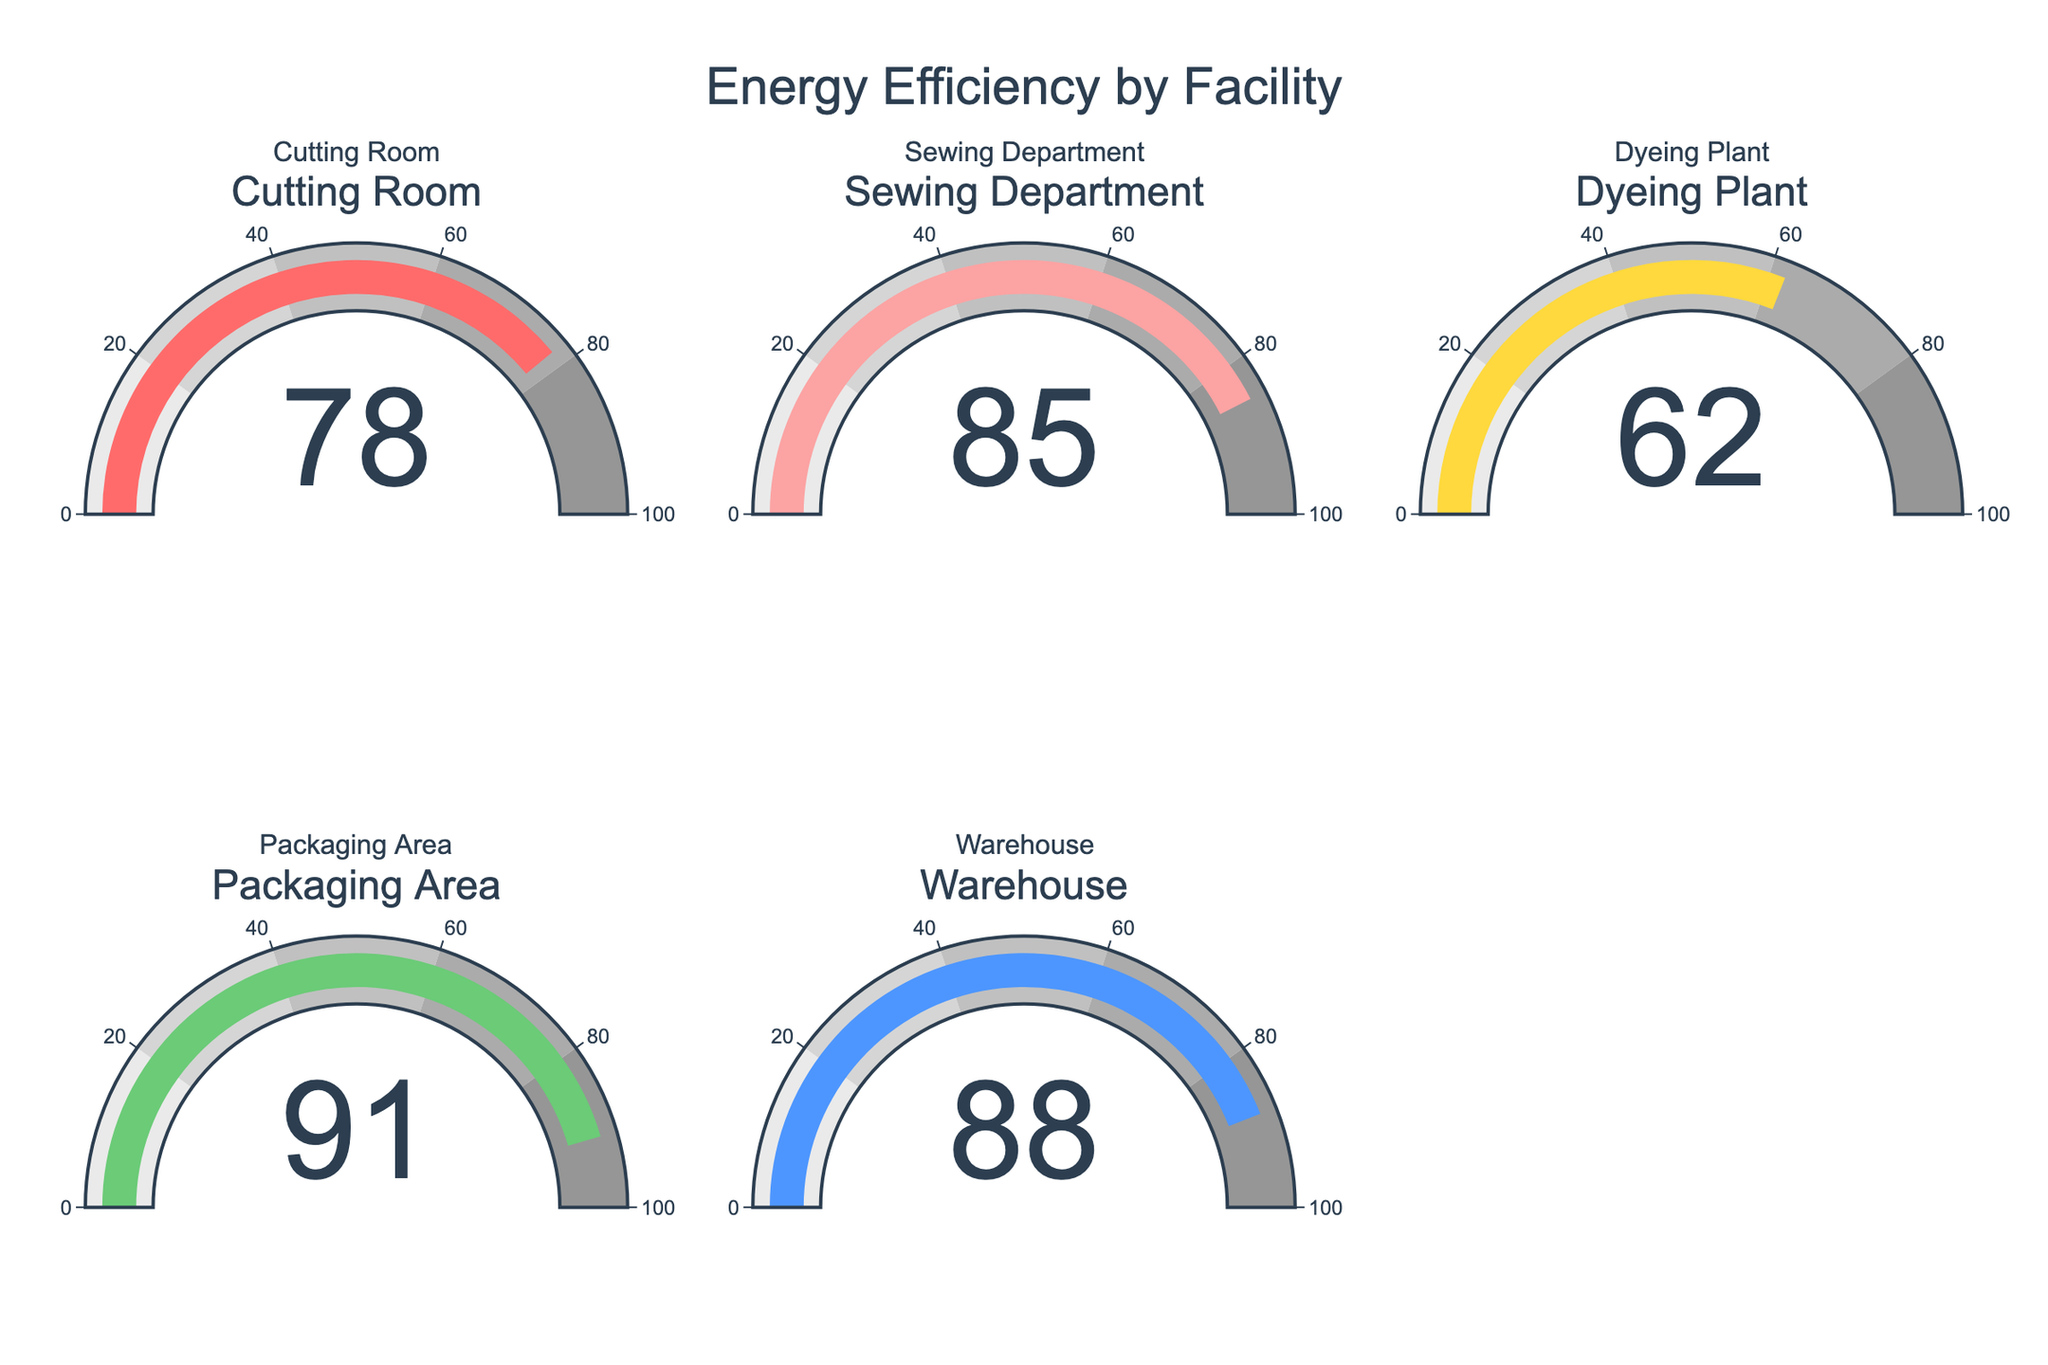Which facility has the highest energy efficiency? Identify the facility with the highest numerical value displayed on its gauge chart. The Packaging Area has a value of 91, which is the highest among all the facilities.
Answer: Packaging Area Which facility's energy efficiency is 62? Look for the gauge chart that shows the value 62. The Dyeing Plant gauge chart displays the value 62.
Answer: Dyeing Plant What's the difference in energy efficiency between the Sewing Department and the Dyeing Plant? Subtract the energy efficiency of the Dyeing Plant (62) from the Sewing Department (85): 85 - 62 = 23.
Answer: 23 What is the average energy efficiency of all facilities? Add the energy efficiency values of all facilities and divide by the number of facilities: (78 + 85 + 62 + 91 + 88) / 5 = 404 / 5 = 80.8.
Answer: 80.8 How many facilities have an energy efficiency greater than 80? Count the number of gauge charts showing values greater than 80: Sewing Department (85), Packaging Area (91), and Warehouse (88). There are 3 such facilities.
Answer: 3 Which facility has the lowest energy efficiency? Identify the facility with the lowest numerical value displayed on its gauge chart. The Dyeing Plant has a value of 62, which is the lowest among all the facilities.
Answer: Dyeing Plant By how many points does the energy efficiency of the Cutting Room lag behind the Packaging Area? Subtract the energy efficiency of the Cutting Room (78) from the Packaging Area (91): 91 - 78 = 13.
Answer: 13 What's the median energy efficiency of the facilities? Arrange the energy efficiency values in ascending order: 62, 78, 85, 88, 91. The median is the middle value, which is 85.
Answer: 85 Which two facilities have the closest energy efficiency values? Find pairs of facilities with the smallest difference in their energy efficiency values: Cutting Room (78) & Sewing Department (85) have a difference of 7, which is the smallest difference among all pairs.
Answer: Cutting Room and Sewing Department What is the combined energy efficiency of the Warehouse and the Packaging Area? Add the energy efficiency values of the Warehouse (88) and the Packaging Area (91): 88 + 91 = 179.
Answer: 179 